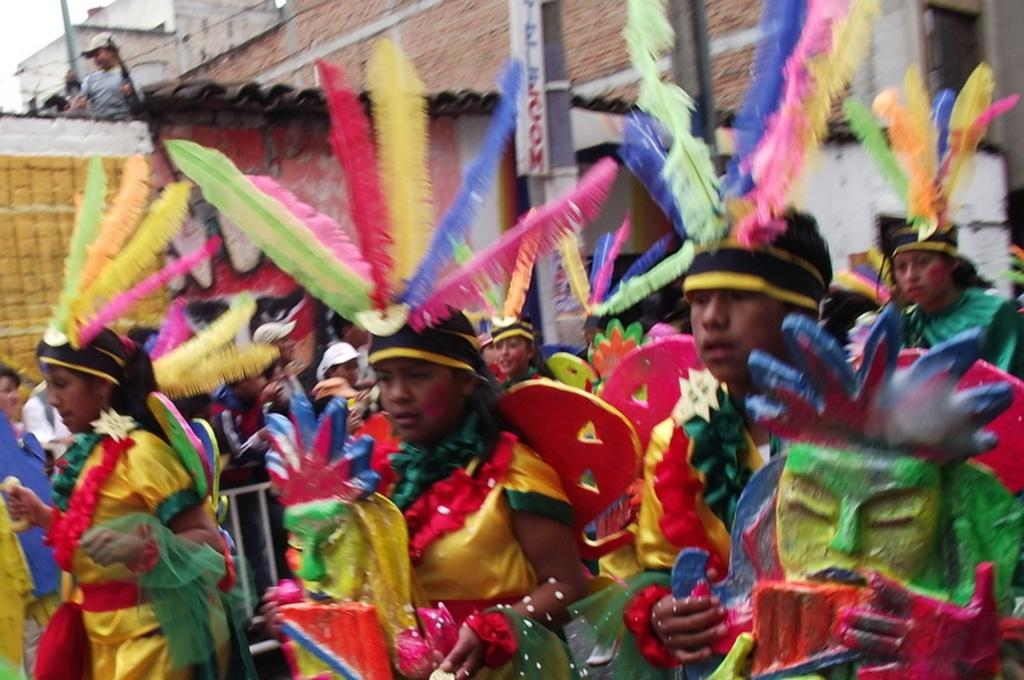What are the people in the image doing? The people in the image are dancing. What are the people wearing while dancing? The people are wearing different costumes. Where are some people standing in the image? Some people are standing on a building. What are the people on the building doing? The people on the building are watching the dancing. What type of nail is being used by the birds in the image? There are no birds or nails present in the image. How is the hose being used by the people in the image? There is no hose present in the image. 